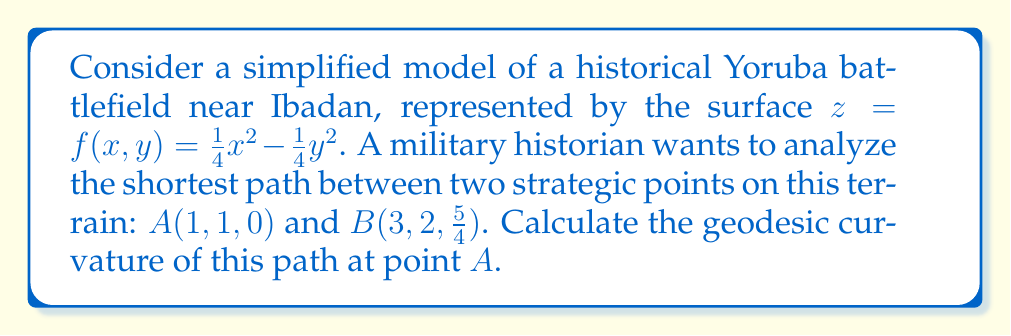Show me your answer to this math problem. To solve this problem, we'll follow these steps:

1) First, we need to calculate the metric tensor $g_{ij}$ for the surface:
   $$f_x = \frac{1}{2}x, \quad f_y = -\frac{1}{2}y$$
   $$g_{11} = 1 + f_x^2 = 1 + \frac{1}{4}x^2$$
   $$g_{22} = 1 + f_y^2 = 1 + \frac{1}{4}y^2$$
   $$g_{12} = g_{21} = f_x f_y = -\frac{1}{4}xy$$

2) At point $A(1,1,0)$:
   $$g_{11} = 1.25, \quad g_{22} = 1.25, \quad g_{12} = g_{21} = -0.25$$

3) The Christoffel symbols at point $A$ are:
   $$\Gamma_{11}^1 = \frac{1}{2g_{11}}(\frac{\partial g_{11}}{\partial x}) = \frac{1}{2(1.25)}(0.5) = 0.2$$
   $$\Gamma_{12}^1 = \Gamma_{21}^1 = \frac{1}{2g_{11}}(\frac{\partial g_{12}}{\partial x}) = \frac{1}{2(1.25)}(-0.25) = -0.1$$
   $$\Gamma_{22}^1 = \frac{1}{2g_{11}}(\frac{\partial g_{22}}{\partial x}) = 0$$
   $$\Gamma_{11}^2 = \frac{1}{2g_{22}}(\frac{\partial g_{11}}{\partial y}) = 0$$
   $$\Gamma_{12}^2 = \Gamma_{21}^2 = \frac{1}{2g_{22}}(\frac{\partial g_{12}}{\partial y}) = \frac{1}{2(1.25)}(-0.25) = -0.1$$
   $$\Gamma_{22}^2 = \frac{1}{2g_{22}}(\frac{\partial g_{22}}{\partial y}) = \frac{1}{2(1.25)}(0.5) = 0.2$$

4) The tangent vector to the geodesic at $A$ is:
   $$T = (\frac{dx}{ds}, \frac{dy}{ds}) = (\frac{2}{\sqrt{5}}, \frac{1}{\sqrt{5}})$$

5) The geodesic curvature is given by:
   $$\kappa_g = \frac{d^2x}{ds^2} + \Gamma_{11}^1(\frac{dx}{ds})^2 + 2\Gamma_{12}^1\frac{dx}{ds}\frac{dy}{ds} + \Gamma_{22}^1(\frac{dy}{ds})^2$$

6) Substituting the values:
   $$\kappa_g = 0 + 0.2(\frac{2}{\sqrt{5}})^2 + 2(-0.1)(\frac{2}{\sqrt{5}})(\frac{1}{\sqrt{5}}) + 0(\frac{1}{\sqrt{5}})^2$$
   $$\kappa_g = 0.16 - 0.08 = 0.08$$

Therefore, the geodesic curvature at point $A$ is 0.08.
Answer: 0.08 